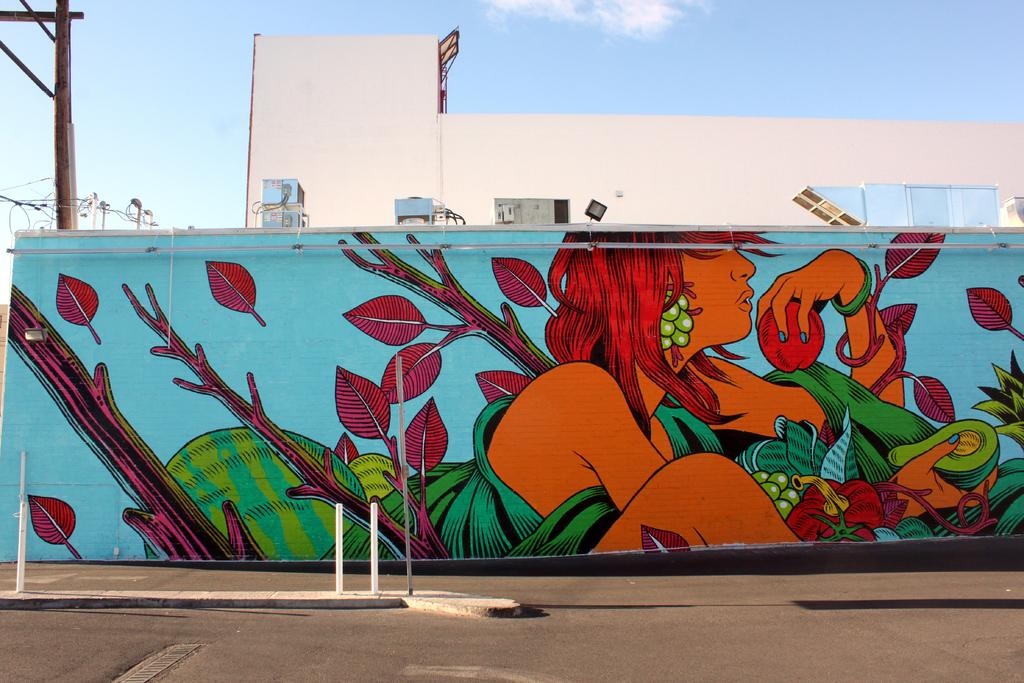What is hanging in the image? There is a banner in the image. What are the banner supported by? The banner is supported by poles and rods in the image. What type of structures can be seen in the image? There are buildings in the image. What else can be seen in the image besides the banner and buildings? There are wires and lights visible in the image. What is at the bottom of the image? There is a road at the bottom of the image. What is visible at the top of the image? The sky is visible at the top of the image. Can you see any clams crawling on the road in the image? There are no clams present in the image; it features a road, buildings, banner, and other objects. What type of division can be seen between the buildings in the image? There is no division mentioned or visible between the buildings in the image. 